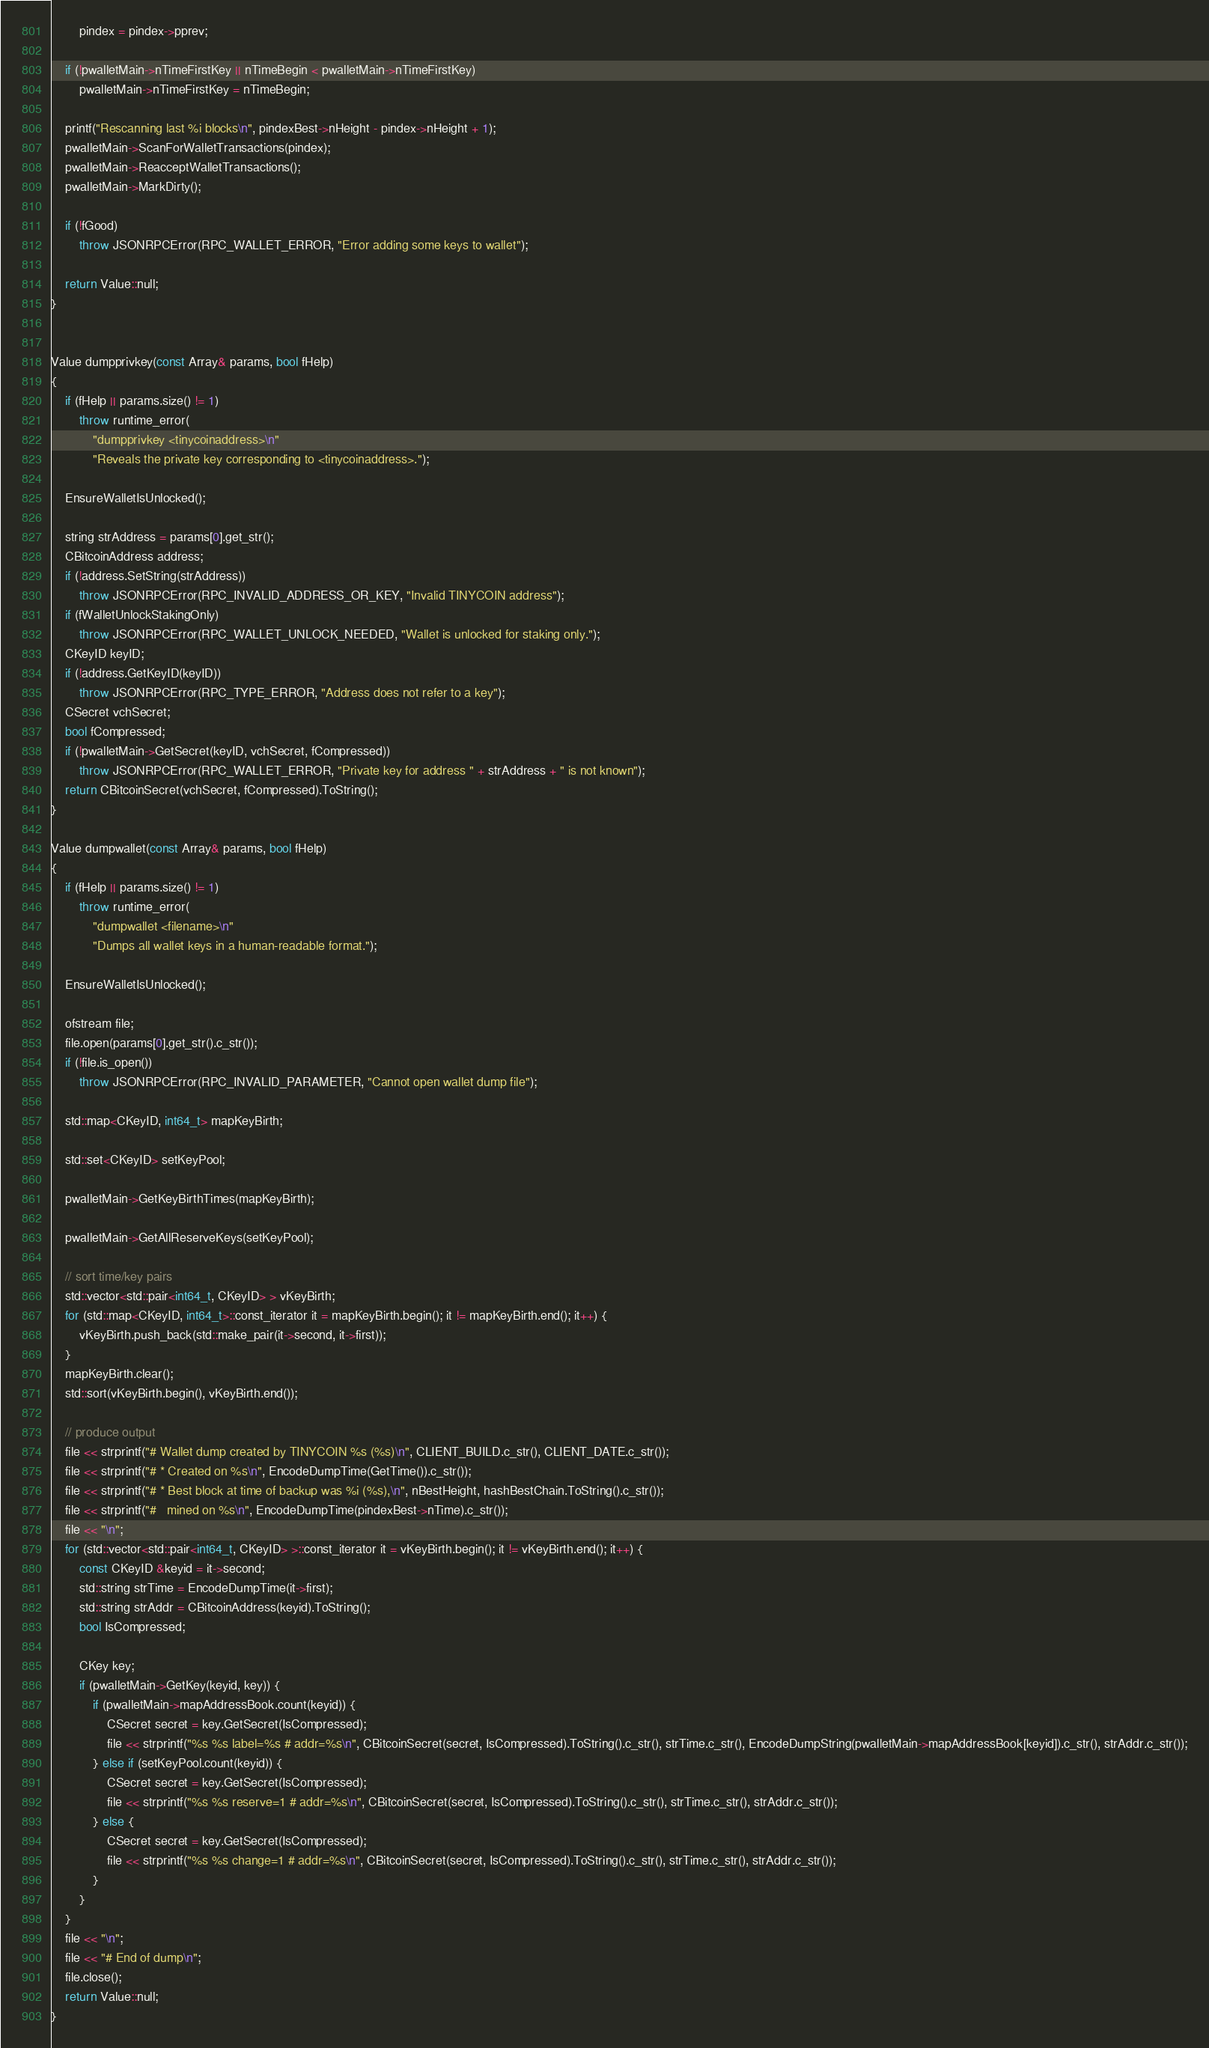Convert code to text. <code><loc_0><loc_0><loc_500><loc_500><_C++_>        pindex = pindex->pprev;

    if (!pwalletMain->nTimeFirstKey || nTimeBegin < pwalletMain->nTimeFirstKey)
        pwalletMain->nTimeFirstKey = nTimeBegin;

    printf("Rescanning last %i blocks\n", pindexBest->nHeight - pindex->nHeight + 1);
    pwalletMain->ScanForWalletTransactions(pindex);
    pwalletMain->ReacceptWalletTransactions();
    pwalletMain->MarkDirty();

    if (!fGood)
        throw JSONRPCError(RPC_WALLET_ERROR, "Error adding some keys to wallet");

    return Value::null;
}


Value dumpprivkey(const Array& params, bool fHelp)
{
    if (fHelp || params.size() != 1)
        throw runtime_error(
            "dumpprivkey <tinycoinaddress>\n"
            "Reveals the private key corresponding to <tinycoinaddress>.");

    EnsureWalletIsUnlocked();

    string strAddress = params[0].get_str();
    CBitcoinAddress address;
    if (!address.SetString(strAddress))
        throw JSONRPCError(RPC_INVALID_ADDRESS_OR_KEY, "Invalid TINYCOIN address");
    if (fWalletUnlockStakingOnly)
        throw JSONRPCError(RPC_WALLET_UNLOCK_NEEDED, "Wallet is unlocked for staking only.");
    CKeyID keyID;
    if (!address.GetKeyID(keyID))
        throw JSONRPCError(RPC_TYPE_ERROR, "Address does not refer to a key");
    CSecret vchSecret;
    bool fCompressed;
    if (!pwalletMain->GetSecret(keyID, vchSecret, fCompressed))
        throw JSONRPCError(RPC_WALLET_ERROR, "Private key for address " + strAddress + " is not known");
    return CBitcoinSecret(vchSecret, fCompressed).ToString();
}

Value dumpwallet(const Array& params, bool fHelp)
{
    if (fHelp || params.size() != 1)
        throw runtime_error(
            "dumpwallet <filename>\n"
            "Dumps all wallet keys in a human-readable format.");

    EnsureWalletIsUnlocked();

    ofstream file;
    file.open(params[0].get_str().c_str());
    if (!file.is_open())
        throw JSONRPCError(RPC_INVALID_PARAMETER, "Cannot open wallet dump file");

    std::map<CKeyID, int64_t> mapKeyBirth;

    std::set<CKeyID> setKeyPool;

    pwalletMain->GetKeyBirthTimes(mapKeyBirth);

    pwalletMain->GetAllReserveKeys(setKeyPool);

    // sort time/key pairs
    std::vector<std::pair<int64_t, CKeyID> > vKeyBirth;
    for (std::map<CKeyID, int64_t>::const_iterator it = mapKeyBirth.begin(); it != mapKeyBirth.end(); it++) {
        vKeyBirth.push_back(std::make_pair(it->second, it->first));
    }
    mapKeyBirth.clear();
    std::sort(vKeyBirth.begin(), vKeyBirth.end());

    // produce output
    file << strprintf("# Wallet dump created by TINYCOIN %s (%s)\n", CLIENT_BUILD.c_str(), CLIENT_DATE.c_str());
    file << strprintf("# * Created on %s\n", EncodeDumpTime(GetTime()).c_str());
    file << strprintf("# * Best block at time of backup was %i (%s),\n", nBestHeight, hashBestChain.ToString().c_str());
    file << strprintf("#   mined on %s\n", EncodeDumpTime(pindexBest->nTime).c_str());
    file << "\n";
    for (std::vector<std::pair<int64_t, CKeyID> >::const_iterator it = vKeyBirth.begin(); it != vKeyBirth.end(); it++) {
        const CKeyID &keyid = it->second;
        std::string strTime = EncodeDumpTime(it->first);
        std::string strAddr = CBitcoinAddress(keyid).ToString();
        bool IsCompressed;

        CKey key;
        if (pwalletMain->GetKey(keyid, key)) {
            if (pwalletMain->mapAddressBook.count(keyid)) {
                CSecret secret = key.GetSecret(IsCompressed);
                file << strprintf("%s %s label=%s # addr=%s\n", CBitcoinSecret(secret, IsCompressed).ToString().c_str(), strTime.c_str(), EncodeDumpString(pwalletMain->mapAddressBook[keyid]).c_str(), strAddr.c_str());
            } else if (setKeyPool.count(keyid)) {
                CSecret secret = key.GetSecret(IsCompressed);
                file << strprintf("%s %s reserve=1 # addr=%s\n", CBitcoinSecret(secret, IsCompressed).ToString().c_str(), strTime.c_str(), strAddr.c_str());
            } else {
                CSecret secret = key.GetSecret(IsCompressed);
                file << strprintf("%s %s change=1 # addr=%s\n", CBitcoinSecret(secret, IsCompressed).ToString().c_str(), strTime.c_str(), strAddr.c_str());
            }
        }
    }
    file << "\n";
    file << "# End of dump\n";
    file.close();
    return Value::null;
}
</code> 